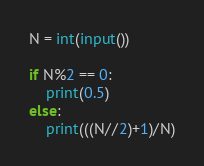Convert code to text. <code><loc_0><loc_0><loc_500><loc_500><_Python_>N = int(input())

if N%2 == 0:
    print(0.5)
else:
    print(((N//2)+1)/N)</code> 